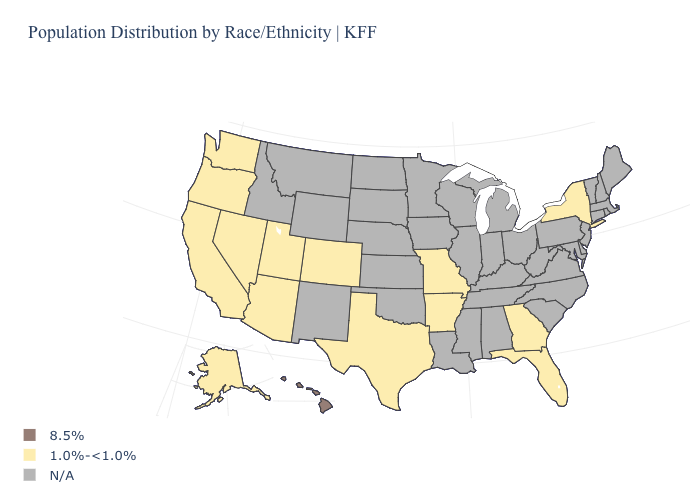What is the lowest value in states that border Wyoming?
Give a very brief answer. 1.0%-<1.0%. Name the states that have a value in the range 1.0%-<1.0%?
Write a very short answer. Alaska, Arizona, Arkansas, California, Colorado, Florida, Georgia, Missouri, Nevada, New York, Oregon, Texas, Utah, Washington. Name the states that have a value in the range 8.5%?
Keep it brief. Hawaii. What is the value of North Carolina?
Be succinct. N/A. What is the highest value in the USA?
Keep it brief. 8.5%. Which states hav the highest value in the South?
Write a very short answer. Arkansas, Florida, Georgia, Texas. Does the map have missing data?
Give a very brief answer. Yes. Name the states that have a value in the range N/A?
Concise answer only. Alabama, Connecticut, Delaware, Idaho, Illinois, Indiana, Iowa, Kansas, Kentucky, Louisiana, Maine, Maryland, Massachusetts, Michigan, Minnesota, Mississippi, Montana, Nebraska, New Hampshire, New Jersey, New Mexico, North Carolina, North Dakota, Ohio, Oklahoma, Pennsylvania, Rhode Island, South Carolina, South Dakota, Tennessee, Vermont, Virginia, West Virginia, Wisconsin, Wyoming. What is the lowest value in states that border Nevada?
Write a very short answer. 1.0%-<1.0%. Does the first symbol in the legend represent the smallest category?
Short answer required. No. 